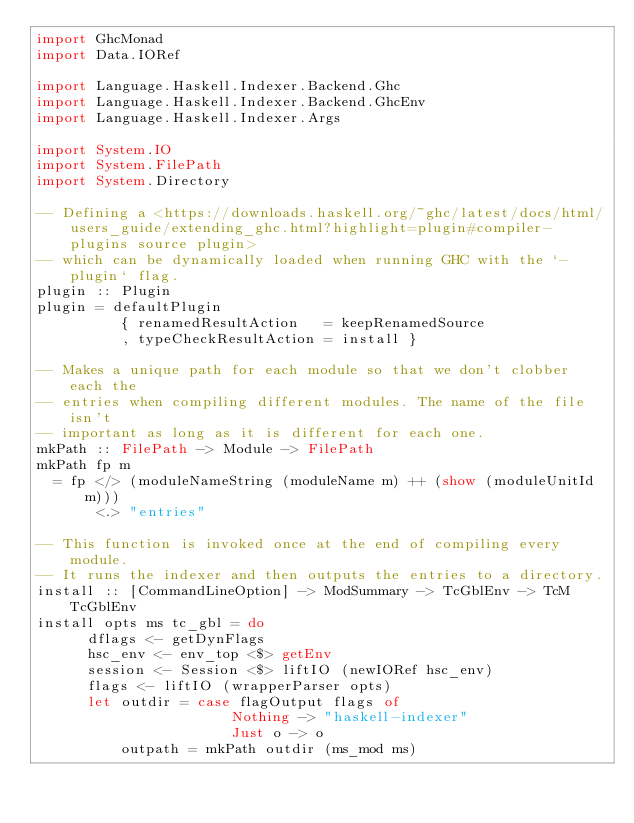Convert code to text. <code><loc_0><loc_0><loc_500><loc_500><_Haskell_>import GhcMonad
import Data.IORef

import Language.Haskell.Indexer.Backend.Ghc
import Language.Haskell.Indexer.Backend.GhcEnv
import Language.Haskell.Indexer.Args

import System.IO
import System.FilePath
import System.Directory

-- Defining a <https://downloads.haskell.org/~ghc/latest/docs/html/users_guide/extending_ghc.html?highlight=plugin#compiler-plugins source plugin>
-- which can be dynamically loaded when running GHC with the `-plugin` flag.
plugin :: Plugin
plugin = defaultPlugin
          { renamedResultAction   = keepRenamedSource
          , typeCheckResultAction = install }

-- Makes a unique path for each module so that we don't clobber each the
-- entries when compiling different modules. The name of the file isn't
-- important as long as it is different for each one.
mkPath :: FilePath -> Module -> FilePath
mkPath fp m
  = fp </> (moduleNameString (moduleName m) ++ (show (moduleUnitId m)))
       <.> "entries"

-- This function is invoked once at the end of compiling every module.
-- It runs the indexer and then outputs the entries to a directory.
install :: [CommandLineOption] -> ModSummary -> TcGblEnv -> TcM TcGblEnv
install opts ms tc_gbl = do
      dflags <- getDynFlags
      hsc_env <- env_top <$> getEnv
      session <- Session <$> liftIO (newIORef hsc_env)
      flags <- liftIO (wrapperParser opts)
      let outdir = case flagOutput flags of
                       Nothing -> "haskell-indexer"
                       Just o -> o
          outpath = mkPath outdir (ms_mod ms)</code> 